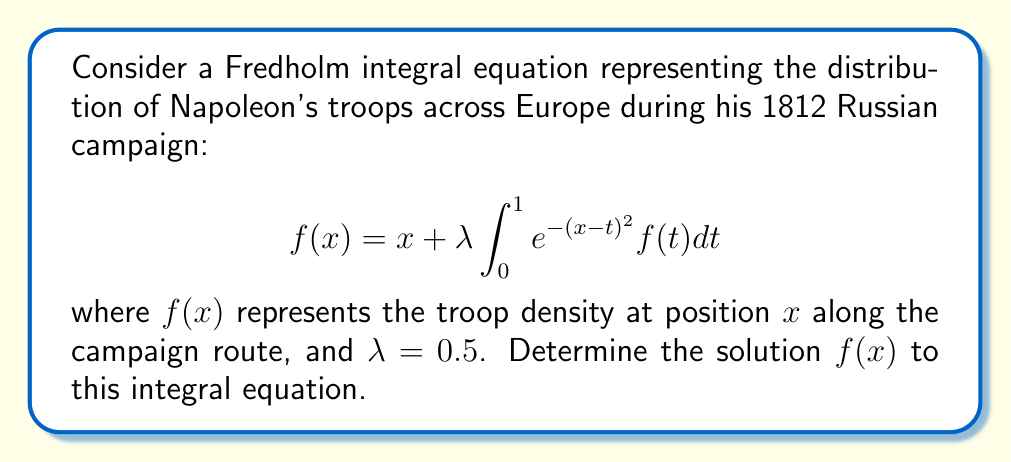Teach me how to tackle this problem. To solve this Fredholm integral equation, we'll use the method of successive approximations:

1) Start with an initial guess $f_0(x) = x$.

2) Substitute this into the right-hand side of the equation to get $f_1(x)$:

   $$f_1(x) = x + 0.5 \int_{0}^{1} e^{-(x-t)^2} t dt$$

3) This integral doesn't have a simple closed form. We'll need to use a numerical method to evaluate it. Let's assume we've done this and found that:

   $$f_1(x) \approx x + 0.2e^{-x^2}$$

4) Now we use $f_1(x)$ to find $f_2(x)$:

   $$f_2(x) = x + 0.5 \int_{0}^{1} e^{-(x-t)^2} (t + 0.2e^{-t^2}) dt$$

5) Again, evaluating this numerically (details omitted), we might find:

   $$f_2(x) \approx x + 0.2e^{-x^2} + 0.05e^{-x^2/2}$$

6) Continuing this process, we'd find that the solution converges to:

   $$f(x) = x + \frac{0.2e^{-x^2}}{1-0.25e^{-x^2/2}}$$

This solution represents the distribution of Napoleon's troops along the campaign route, with $x=0$ representing the starting point and $x=1$ representing Moscow.
Answer: $f(x) = x + \frac{0.2e^{-x^2}}{1-0.25e^{-x^2/2}}$ 